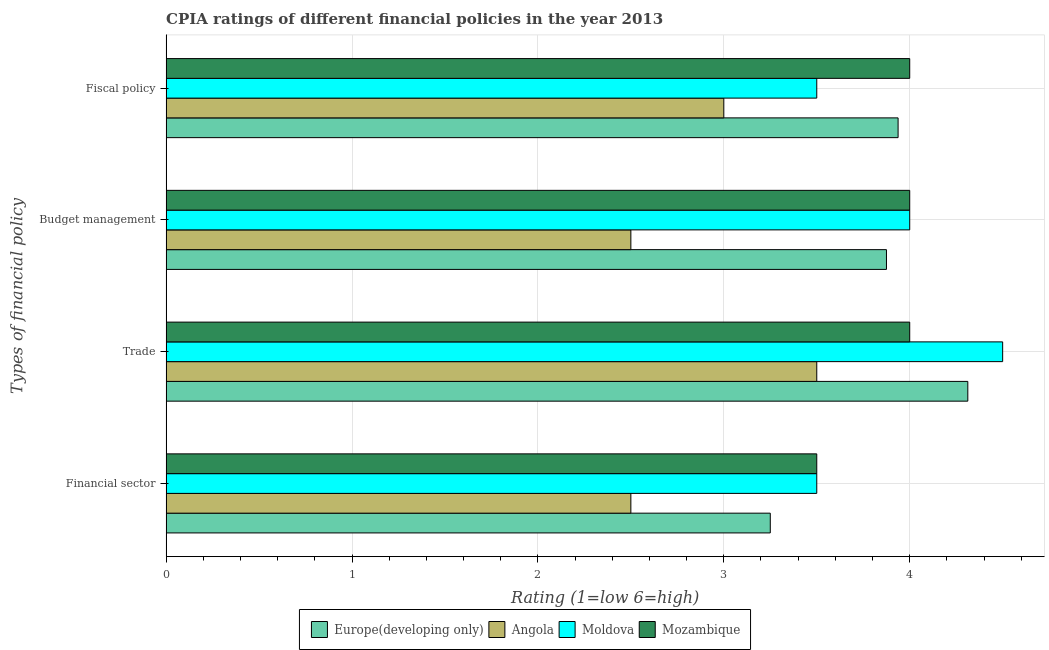How many different coloured bars are there?
Provide a succinct answer. 4. Are the number of bars on each tick of the Y-axis equal?
Your answer should be compact. Yes. How many bars are there on the 1st tick from the bottom?
Make the answer very short. 4. What is the label of the 4th group of bars from the top?
Your answer should be compact. Financial sector. What is the cpia rating of budget management in Europe(developing only)?
Give a very brief answer. 3.88. Across all countries, what is the minimum cpia rating of trade?
Your answer should be very brief. 3.5. In which country was the cpia rating of fiscal policy maximum?
Your answer should be compact. Mozambique. In which country was the cpia rating of fiscal policy minimum?
Offer a terse response. Angola. What is the total cpia rating of trade in the graph?
Give a very brief answer. 16.31. What is the difference between the cpia rating of budget management in Europe(developing only) and that in Angola?
Make the answer very short. 1.38. What is the difference between the cpia rating of fiscal policy in Angola and the cpia rating of financial sector in Mozambique?
Provide a succinct answer. -0.5. What is the average cpia rating of fiscal policy per country?
Provide a succinct answer. 3.61. What is the difference between the cpia rating of budget management and cpia rating of fiscal policy in Moldova?
Ensure brevity in your answer.  0.5. In how many countries, is the cpia rating of fiscal policy greater than 1.2 ?
Your response must be concise. 4. What is the ratio of the cpia rating of financial sector in Moldova to that in Europe(developing only)?
Make the answer very short. 1.08. What is the difference between the highest and the second highest cpia rating of fiscal policy?
Give a very brief answer. 0.06. What is the difference between the highest and the lowest cpia rating of financial sector?
Give a very brief answer. 1. In how many countries, is the cpia rating of fiscal policy greater than the average cpia rating of fiscal policy taken over all countries?
Offer a terse response. 2. Is it the case that in every country, the sum of the cpia rating of budget management and cpia rating of fiscal policy is greater than the sum of cpia rating of trade and cpia rating of financial sector?
Your response must be concise. No. What does the 2nd bar from the top in Financial sector represents?
Provide a succinct answer. Moldova. What does the 4th bar from the bottom in Budget management represents?
Ensure brevity in your answer.  Mozambique. Is it the case that in every country, the sum of the cpia rating of financial sector and cpia rating of trade is greater than the cpia rating of budget management?
Keep it short and to the point. Yes. How many countries are there in the graph?
Your answer should be compact. 4. What is the difference between two consecutive major ticks on the X-axis?
Make the answer very short. 1. Does the graph contain any zero values?
Your answer should be very brief. No. Does the graph contain grids?
Your answer should be compact. Yes. Where does the legend appear in the graph?
Your answer should be compact. Bottom center. How many legend labels are there?
Keep it short and to the point. 4. What is the title of the graph?
Provide a short and direct response. CPIA ratings of different financial policies in the year 2013. What is the label or title of the Y-axis?
Provide a short and direct response. Types of financial policy. What is the Rating (1=low 6=high) in Europe(developing only) in Financial sector?
Your answer should be very brief. 3.25. What is the Rating (1=low 6=high) of Angola in Financial sector?
Offer a terse response. 2.5. What is the Rating (1=low 6=high) of Moldova in Financial sector?
Offer a very short reply. 3.5. What is the Rating (1=low 6=high) in Mozambique in Financial sector?
Provide a succinct answer. 3.5. What is the Rating (1=low 6=high) of Europe(developing only) in Trade?
Keep it short and to the point. 4.31. What is the Rating (1=low 6=high) of Mozambique in Trade?
Your response must be concise. 4. What is the Rating (1=low 6=high) of Europe(developing only) in Budget management?
Provide a short and direct response. 3.88. What is the Rating (1=low 6=high) of Europe(developing only) in Fiscal policy?
Provide a succinct answer. 3.94. What is the Rating (1=low 6=high) of Angola in Fiscal policy?
Your answer should be very brief. 3. What is the Rating (1=low 6=high) in Mozambique in Fiscal policy?
Offer a very short reply. 4. Across all Types of financial policy, what is the maximum Rating (1=low 6=high) of Europe(developing only)?
Offer a very short reply. 4.31. Across all Types of financial policy, what is the maximum Rating (1=low 6=high) of Angola?
Ensure brevity in your answer.  3.5. Across all Types of financial policy, what is the maximum Rating (1=low 6=high) in Moldova?
Ensure brevity in your answer.  4.5. Across all Types of financial policy, what is the minimum Rating (1=low 6=high) in Europe(developing only)?
Make the answer very short. 3.25. Across all Types of financial policy, what is the minimum Rating (1=low 6=high) of Angola?
Offer a very short reply. 2.5. Across all Types of financial policy, what is the minimum Rating (1=low 6=high) of Moldova?
Your response must be concise. 3.5. What is the total Rating (1=low 6=high) of Europe(developing only) in the graph?
Provide a succinct answer. 15.38. What is the total Rating (1=low 6=high) of Mozambique in the graph?
Make the answer very short. 15.5. What is the difference between the Rating (1=low 6=high) of Europe(developing only) in Financial sector and that in Trade?
Keep it short and to the point. -1.06. What is the difference between the Rating (1=low 6=high) of Moldova in Financial sector and that in Trade?
Keep it short and to the point. -1. What is the difference between the Rating (1=low 6=high) in Europe(developing only) in Financial sector and that in Budget management?
Give a very brief answer. -0.62. What is the difference between the Rating (1=low 6=high) in Angola in Financial sector and that in Budget management?
Offer a terse response. 0. What is the difference between the Rating (1=low 6=high) in Europe(developing only) in Financial sector and that in Fiscal policy?
Offer a terse response. -0.69. What is the difference between the Rating (1=low 6=high) in Mozambique in Financial sector and that in Fiscal policy?
Make the answer very short. -0.5. What is the difference between the Rating (1=low 6=high) of Europe(developing only) in Trade and that in Budget management?
Offer a terse response. 0.44. What is the difference between the Rating (1=low 6=high) of Angola in Trade and that in Budget management?
Your answer should be very brief. 1. What is the difference between the Rating (1=low 6=high) of Moldova in Trade and that in Budget management?
Keep it short and to the point. 0.5. What is the difference between the Rating (1=low 6=high) in Mozambique in Trade and that in Budget management?
Provide a succinct answer. 0. What is the difference between the Rating (1=low 6=high) of Angola in Trade and that in Fiscal policy?
Your answer should be very brief. 0.5. What is the difference between the Rating (1=low 6=high) of Moldova in Trade and that in Fiscal policy?
Give a very brief answer. 1. What is the difference between the Rating (1=low 6=high) in Mozambique in Trade and that in Fiscal policy?
Keep it short and to the point. 0. What is the difference between the Rating (1=low 6=high) of Europe(developing only) in Budget management and that in Fiscal policy?
Ensure brevity in your answer.  -0.06. What is the difference between the Rating (1=low 6=high) of Moldova in Budget management and that in Fiscal policy?
Give a very brief answer. 0.5. What is the difference between the Rating (1=low 6=high) in Mozambique in Budget management and that in Fiscal policy?
Your response must be concise. 0. What is the difference between the Rating (1=low 6=high) of Europe(developing only) in Financial sector and the Rating (1=low 6=high) of Angola in Trade?
Your response must be concise. -0.25. What is the difference between the Rating (1=low 6=high) of Europe(developing only) in Financial sector and the Rating (1=low 6=high) of Moldova in Trade?
Your answer should be compact. -1.25. What is the difference between the Rating (1=low 6=high) in Europe(developing only) in Financial sector and the Rating (1=low 6=high) in Mozambique in Trade?
Keep it short and to the point. -0.75. What is the difference between the Rating (1=low 6=high) in Angola in Financial sector and the Rating (1=low 6=high) in Moldova in Trade?
Provide a succinct answer. -2. What is the difference between the Rating (1=low 6=high) in Moldova in Financial sector and the Rating (1=low 6=high) in Mozambique in Trade?
Make the answer very short. -0.5. What is the difference between the Rating (1=low 6=high) in Europe(developing only) in Financial sector and the Rating (1=low 6=high) in Angola in Budget management?
Your response must be concise. 0.75. What is the difference between the Rating (1=low 6=high) in Europe(developing only) in Financial sector and the Rating (1=low 6=high) in Moldova in Budget management?
Provide a succinct answer. -0.75. What is the difference between the Rating (1=low 6=high) of Europe(developing only) in Financial sector and the Rating (1=low 6=high) of Mozambique in Budget management?
Your answer should be very brief. -0.75. What is the difference between the Rating (1=low 6=high) of Angola in Financial sector and the Rating (1=low 6=high) of Moldova in Budget management?
Your answer should be very brief. -1.5. What is the difference between the Rating (1=low 6=high) in Angola in Financial sector and the Rating (1=low 6=high) in Mozambique in Budget management?
Keep it short and to the point. -1.5. What is the difference between the Rating (1=low 6=high) in Europe(developing only) in Financial sector and the Rating (1=low 6=high) in Angola in Fiscal policy?
Offer a very short reply. 0.25. What is the difference between the Rating (1=low 6=high) in Europe(developing only) in Financial sector and the Rating (1=low 6=high) in Mozambique in Fiscal policy?
Offer a very short reply. -0.75. What is the difference between the Rating (1=low 6=high) in Angola in Financial sector and the Rating (1=low 6=high) in Mozambique in Fiscal policy?
Provide a short and direct response. -1.5. What is the difference between the Rating (1=low 6=high) of Moldova in Financial sector and the Rating (1=low 6=high) of Mozambique in Fiscal policy?
Ensure brevity in your answer.  -0.5. What is the difference between the Rating (1=low 6=high) of Europe(developing only) in Trade and the Rating (1=low 6=high) of Angola in Budget management?
Keep it short and to the point. 1.81. What is the difference between the Rating (1=low 6=high) of Europe(developing only) in Trade and the Rating (1=low 6=high) of Moldova in Budget management?
Provide a short and direct response. 0.31. What is the difference between the Rating (1=low 6=high) in Europe(developing only) in Trade and the Rating (1=low 6=high) in Mozambique in Budget management?
Provide a short and direct response. 0.31. What is the difference between the Rating (1=low 6=high) in Moldova in Trade and the Rating (1=low 6=high) in Mozambique in Budget management?
Provide a short and direct response. 0.5. What is the difference between the Rating (1=low 6=high) of Europe(developing only) in Trade and the Rating (1=low 6=high) of Angola in Fiscal policy?
Ensure brevity in your answer.  1.31. What is the difference between the Rating (1=low 6=high) in Europe(developing only) in Trade and the Rating (1=low 6=high) in Moldova in Fiscal policy?
Provide a succinct answer. 0.81. What is the difference between the Rating (1=low 6=high) of Europe(developing only) in Trade and the Rating (1=low 6=high) of Mozambique in Fiscal policy?
Provide a short and direct response. 0.31. What is the difference between the Rating (1=low 6=high) of Angola in Trade and the Rating (1=low 6=high) of Moldova in Fiscal policy?
Your response must be concise. 0. What is the difference between the Rating (1=low 6=high) of Moldova in Trade and the Rating (1=low 6=high) of Mozambique in Fiscal policy?
Ensure brevity in your answer.  0.5. What is the difference between the Rating (1=low 6=high) in Europe(developing only) in Budget management and the Rating (1=low 6=high) in Moldova in Fiscal policy?
Make the answer very short. 0.38. What is the difference between the Rating (1=low 6=high) in Europe(developing only) in Budget management and the Rating (1=low 6=high) in Mozambique in Fiscal policy?
Keep it short and to the point. -0.12. What is the difference between the Rating (1=low 6=high) of Moldova in Budget management and the Rating (1=low 6=high) of Mozambique in Fiscal policy?
Offer a terse response. 0. What is the average Rating (1=low 6=high) in Europe(developing only) per Types of financial policy?
Keep it short and to the point. 3.84. What is the average Rating (1=low 6=high) in Angola per Types of financial policy?
Make the answer very short. 2.88. What is the average Rating (1=low 6=high) of Moldova per Types of financial policy?
Your answer should be compact. 3.88. What is the average Rating (1=low 6=high) of Mozambique per Types of financial policy?
Offer a very short reply. 3.88. What is the difference between the Rating (1=low 6=high) of Europe(developing only) and Rating (1=low 6=high) of Mozambique in Financial sector?
Keep it short and to the point. -0.25. What is the difference between the Rating (1=low 6=high) in Angola and Rating (1=low 6=high) in Moldova in Financial sector?
Keep it short and to the point. -1. What is the difference between the Rating (1=low 6=high) in Europe(developing only) and Rating (1=low 6=high) in Angola in Trade?
Your answer should be compact. 0.81. What is the difference between the Rating (1=low 6=high) in Europe(developing only) and Rating (1=low 6=high) in Moldova in Trade?
Your answer should be very brief. -0.19. What is the difference between the Rating (1=low 6=high) of Europe(developing only) and Rating (1=low 6=high) of Mozambique in Trade?
Your answer should be very brief. 0.31. What is the difference between the Rating (1=low 6=high) in Moldova and Rating (1=low 6=high) in Mozambique in Trade?
Offer a very short reply. 0.5. What is the difference between the Rating (1=low 6=high) of Europe(developing only) and Rating (1=low 6=high) of Angola in Budget management?
Your response must be concise. 1.38. What is the difference between the Rating (1=low 6=high) in Europe(developing only) and Rating (1=low 6=high) in Moldova in Budget management?
Provide a succinct answer. -0.12. What is the difference between the Rating (1=low 6=high) in Europe(developing only) and Rating (1=low 6=high) in Mozambique in Budget management?
Your response must be concise. -0.12. What is the difference between the Rating (1=low 6=high) of Europe(developing only) and Rating (1=low 6=high) of Angola in Fiscal policy?
Your answer should be very brief. 0.94. What is the difference between the Rating (1=low 6=high) in Europe(developing only) and Rating (1=low 6=high) in Moldova in Fiscal policy?
Provide a short and direct response. 0.44. What is the difference between the Rating (1=low 6=high) of Europe(developing only) and Rating (1=low 6=high) of Mozambique in Fiscal policy?
Make the answer very short. -0.06. What is the difference between the Rating (1=low 6=high) in Angola and Rating (1=low 6=high) in Moldova in Fiscal policy?
Offer a very short reply. -0.5. What is the ratio of the Rating (1=low 6=high) in Europe(developing only) in Financial sector to that in Trade?
Your answer should be compact. 0.75. What is the ratio of the Rating (1=low 6=high) of Angola in Financial sector to that in Trade?
Ensure brevity in your answer.  0.71. What is the ratio of the Rating (1=low 6=high) in Mozambique in Financial sector to that in Trade?
Provide a succinct answer. 0.88. What is the ratio of the Rating (1=low 6=high) in Europe(developing only) in Financial sector to that in Budget management?
Provide a succinct answer. 0.84. What is the ratio of the Rating (1=low 6=high) of Moldova in Financial sector to that in Budget management?
Provide a succinct answer. 0.88. What is the ratio of the Rating (1=low 6=high) in Mozambique in Financial sector to that in Budget management?
Keep it short and to the point. 0.88. What is the ratio of the Rating (1=low 6=high) of Europe(developing only) in Financial sector to that in Fiscal policy?
Make the answer very short. 0.83. What is the ratio of the Rating (1=low 6=high) in Europe(developing only) in Trade to that in Budget management?
Provide a succinct answer. 1.11. What is the ratio of the Rating (1=low 6=high) of Moldova in Trade to that in Budget management?
Give a very brief answer. 1.12. What is the ratio of the Rating (1=low 6=high) in Europe(developing only) in Trade to that in Fiscal policy?
Keep it short and to the point. 1.1. What is the ratio of the Rating (1=low 6=high) in Angola in Trade to that in Fiscal policy?
Your answer should be compact. 1.17. What is the ratio of the Rating (1=low 6=high) of Moldova in Trade to that in Fiscal policy?
Give a very brief answer. 1.29. What is the ratio of the Rating (1=low 6=high) in Mozambique in Trade to that in Fiscal policy?
Ensure brevity in your answer.  1. What is the ratio of the Rating (1=low 6=high) of Europe(developing only) in Budget management to that in Fiscal policy?
Give a very brief answer. 0.98. What is the ratio of the Rating (1=low 6=high) in Angola in Budget management to that in Fiscal policy?
Your response must be concise. 0.83. What is the difference between the highest and the second highest Rating (1=low 6=high) of Europe(developing only)?
Keep it short and to the point. 0.38. What is the difference between the highest and the second highest Rating (1=low 6=high) in Angola?
Make the answer very short. 0.5. What is the difference between the highest and the lowest Rating (1=low 6=high) of Europe(developing only)?
Offer a terse response. 1.06. What is the difference between the highest and the lowest Rating (1=low 6=high) of Moldova?
Offer a very short reply. 1. What is the difference between the highest and the lowest Rating (1=low 6=high) in Mozambique?
Give a very brief answer. 0.5. 